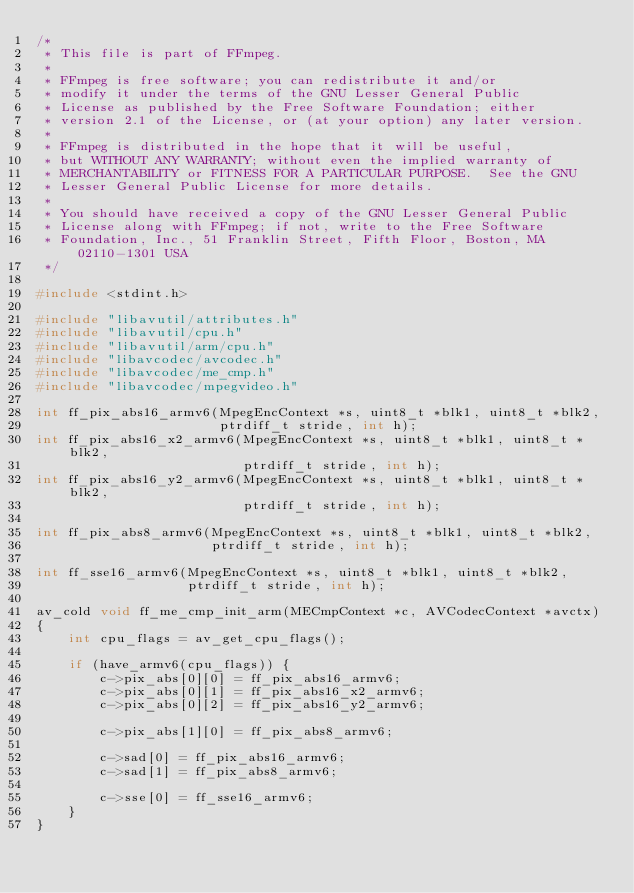Convert code to text. <code><loc_0><loc_0><loc_500><loc_500><_C_>/*
 * This file is part of FFmpeg.
 *
 * FFmpeg is free software; you can redistribute it and/or
 * modify it under the terms of the GNU Lesser General Public
 * License as published by the Free Software Foundation; either
 * version 2.1 of the License, or (at your option) any later version.
 *
 * FFmpeg is distributed in the hope that it will be useful,
 * but WITHOUT ANY WARRANTY; without even the implied warranty of
 * MERCHANTABILITY or FITNESS FOR A PARTICULAR PURPOSE.  See the GNU
 * Lesser General Public License for more details.
 *
 * You should have received a copy of the GNU Lesser General Public
 * License along with FFmpeg; if not, write to the Free Software
 * Foundation, Inc., 51 Franklin Street, Fifth Floor, Boston, MA 02110-1301 USA
 */

#include <stdint.h>

#include "libavutil/attributes.h"
#include "libavutil/cpu.h"
#include "libavutil/arm/cpu.h"
#include "libavcodec/avcodec.h"
#include "libavcodec/me_cmp.h"
#include "libavcodec/mpegvideo.h"

int ff_pix_abs16_armv6(MpegEncContext *s, uint8_t *blk1, uint8_t *blk2,
                       ptrdiff_t stride, int h);
int ff_pix_abs16_x2_armv6(MpegEncContext *s, uint8_t *blk1, uint8_t *blk2,
                          ptrdiff_t stride, int h);
int ff_pix_abs16_y2_armv6(MpegEncContext *s, uint8_t *blk1, uint8_t *blk2,
                          ptrdiff_t stride, int h);

int ff_pix_abs8_armv6(MpegEncContext *s, uint8_t *blk1, uint8_t *blk2,
                      ptrdiff_t stride, int h);

int ff_sse16_armv6(MpegEncContext *s, uint8_t *blk1, uint8_t *blk2,
                   ptrdiff_t stride, int h);

av_cold void ff_me_cmp_init_arm(MECmpContext *c, AVCodecContext *avctx)
{
    int cpu_flags = av_get_cpu_flags();

    if (have_armv6(cpu_flags)) {
        c->pix_abs[0][0] = ff_pix_abs16_armv6;
        c->pix_abs[0][1] = ff_pix_abs16_x2_armv6;
        c->pix_abs[0][2] = ff_pix_abs16_y2_armv6;

        c->pix_abs[1][0] = ff_pix_abs8_armv6;

        c->sad[0] = ff_pix_abs16_armv6;
        c->sad[1] = ff_pix_abs8_armv6;

        c->sse[0] = ff_sse16_armv6;
    }
}
</code> 